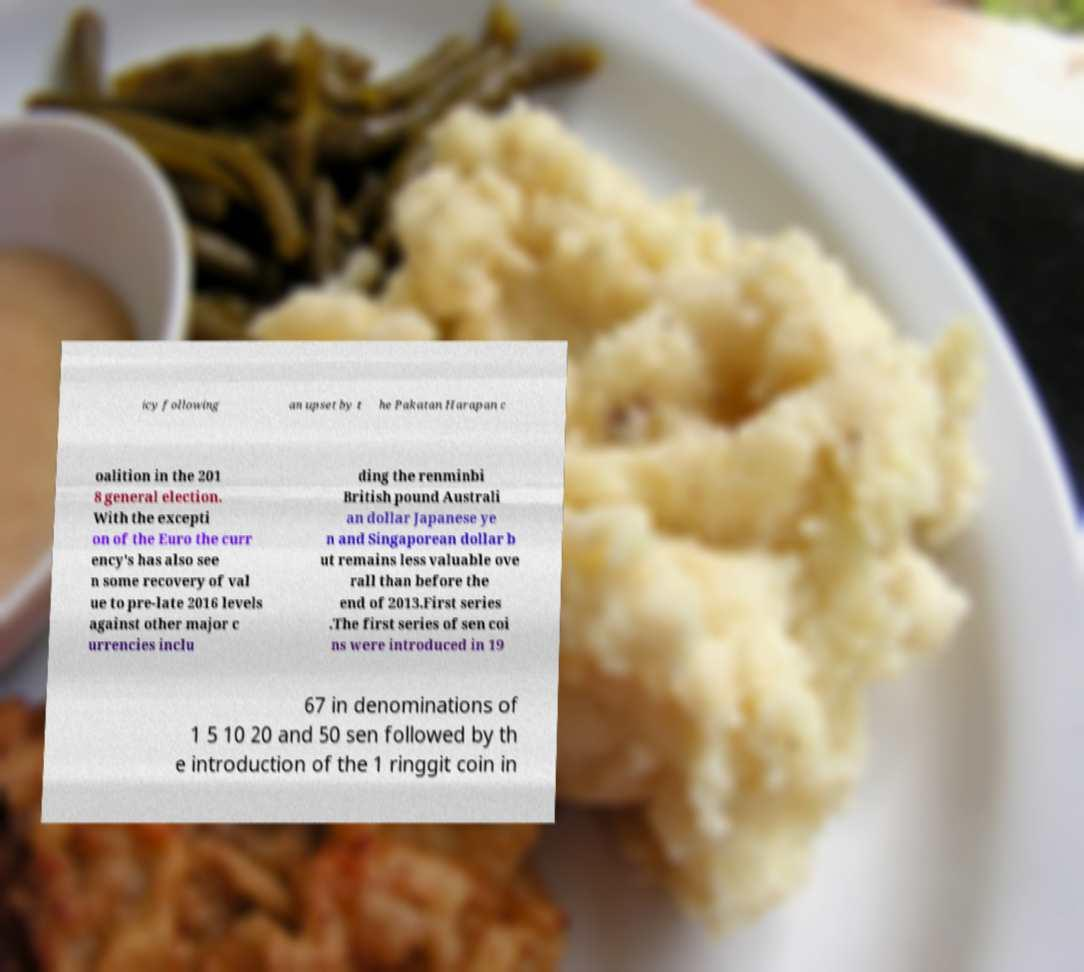Can you read and provide the text displayed in the image?This photo seems to have some interesting text. Can you extract and type it out for me? icy following an upset by t he Pakatan Harapan c oalition in the 201 8 general election. With the excepti on of the Euro the curr ency's has also see n some recovery of val ue to pre-late 2016 levels against other major c urrencies inclu ding the renminbi British pound Australi an dollar Japanese ye n and Singaporean dollar b ut remains less valuable ove rall than before the end of 2013.First series .The first series of sen coi ns were introduced in 19 67 in denominations of 1 5 10 20 and 50 sen followed by th e introduction of the 1 ringgit coin in 